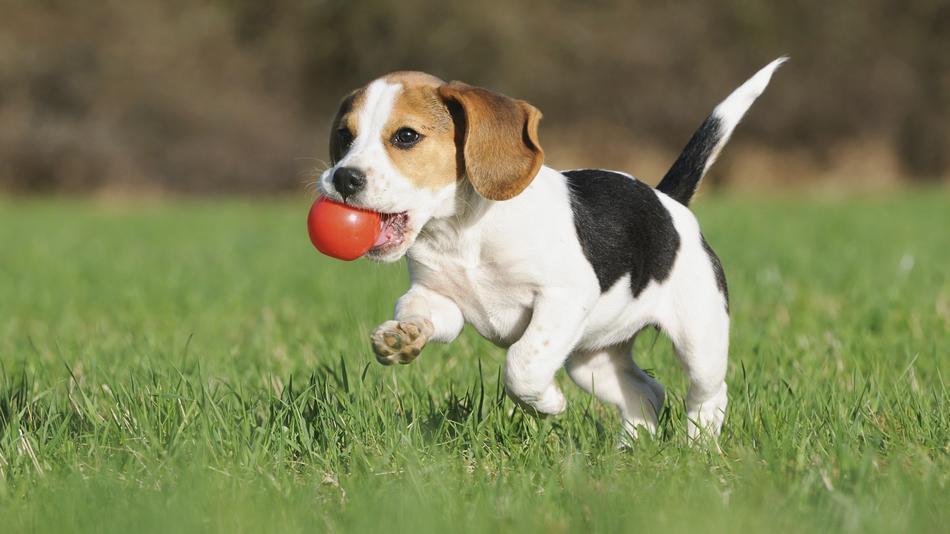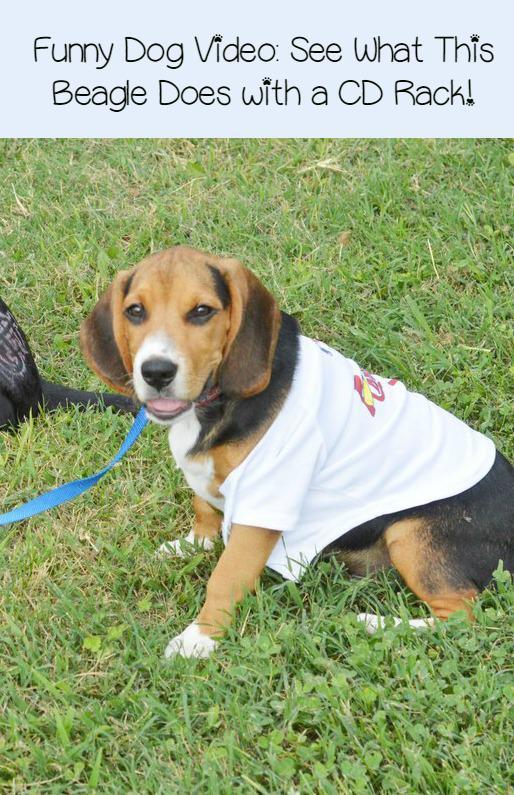The first image is the image on the left, the second image is the image on the right. Given the left and right images, does the statement "There are 3 or more puppies playing outside." hold true? Answer yes or no. No. The first image is the image on the left, the second image is the image on the right. Examine the images to the left and right. Is the description "there is a dog  with a ball in its mouth on a grassy lawn" accurate? Answer yes or no. Yes. 